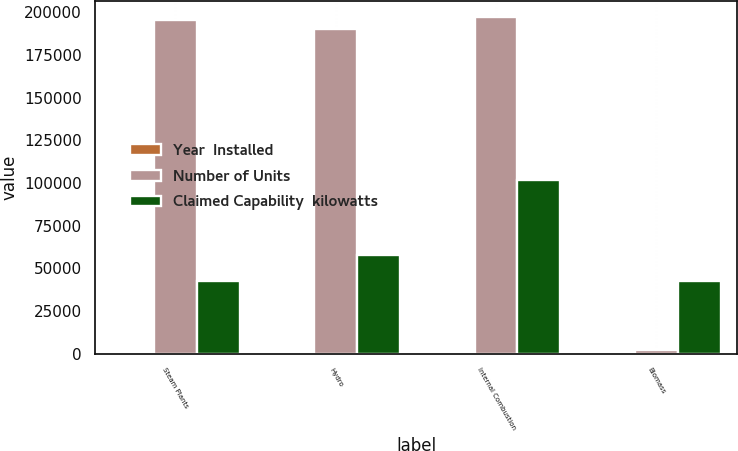Convert chart. <chart><loc_0><loc_0><loc_500><loc_500><stacked_bar_chart><ecel><fcel>Steam Plants<fcel>Hydro<fcel>Internal Combustion<fcel>Biomass<nl><fcel>Year  Installed<fcel>5<fcel>20<fcel>5<fcel>1<nl><fcel>Number of Units<fcel>195274<fcel>190183<fcel>196870<fcel>2006<nl><fcel>Claimed Capability  kilowatts<fcel>42594<fcel>58115<fcel>101869<fcel>42594<nl></chart> 